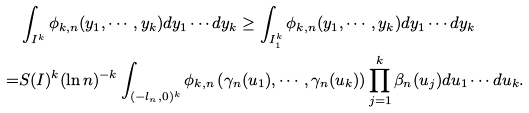<formula> <loc_0><loc_0><loc_500><loc_500>& \int _ { I ^ { k } } \phi _ { k , n } ( y _ { 1 } , \cdots , y _ { k } ) d y _ { 1 } \cdots d y _ { k } \geq \int _ { I _ { 1 } ^ { k } } \phi _ { k , n } ( y _ { 1 } , \cdots , y _ { k } ) d y _ { 1 } \cdots d y _ { k } \\ = & S ( I ) ^ { k } ( \ln n ) ^ { - k } \int _ { ( - l _ { n } , 0 ) ^ { k } } \phi _ { k , n } \left ( \gamma _ { n } ( u _ { 1 } ) , \cdots , \gamma _ { n } ( u _ { k } ) \right ) \prod _ { j = 1 } ^ { k } \beta _ { n } ( u _ { j } ) d u _ { 1 } \cdots d u _ { k } .</formula> 